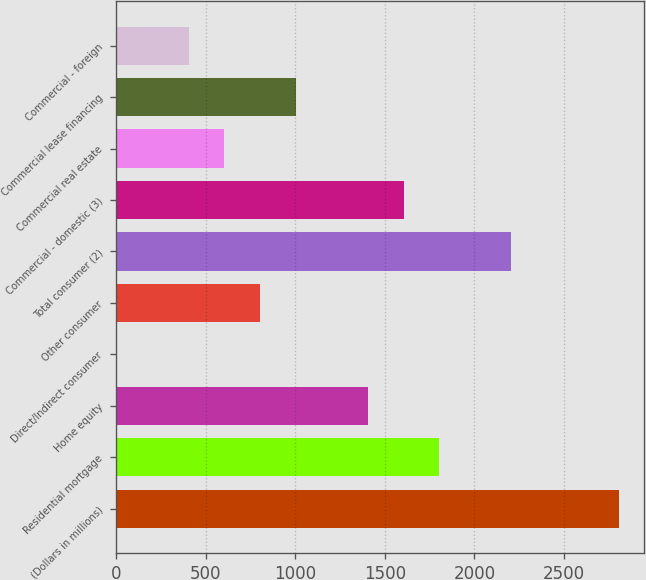Convert chart to OTSL. <chart><loc_0><loc_0><loc_500><loc_500><bar_chart><fcel>(Dollars in millions)<fcel>Residential mortgage<fcel>Home equity<fcel>Direct/Indirect consumer<fcel>Other consumer<fcel>Total consumer (2)<fcel>Commercial - domestic (3)<fcel>Commercial real estate<fcel>Commercial lease financing<fcel>Commercial - foreign<nl><fcel>2805.8<fcel>1804.8<fcel>1404.4<fcel>3<fcel>803.8<fcel>2205.2<fcel>1604.6<fcel>603.6<fcel>1004<fcel>403.4<nl></chart> 